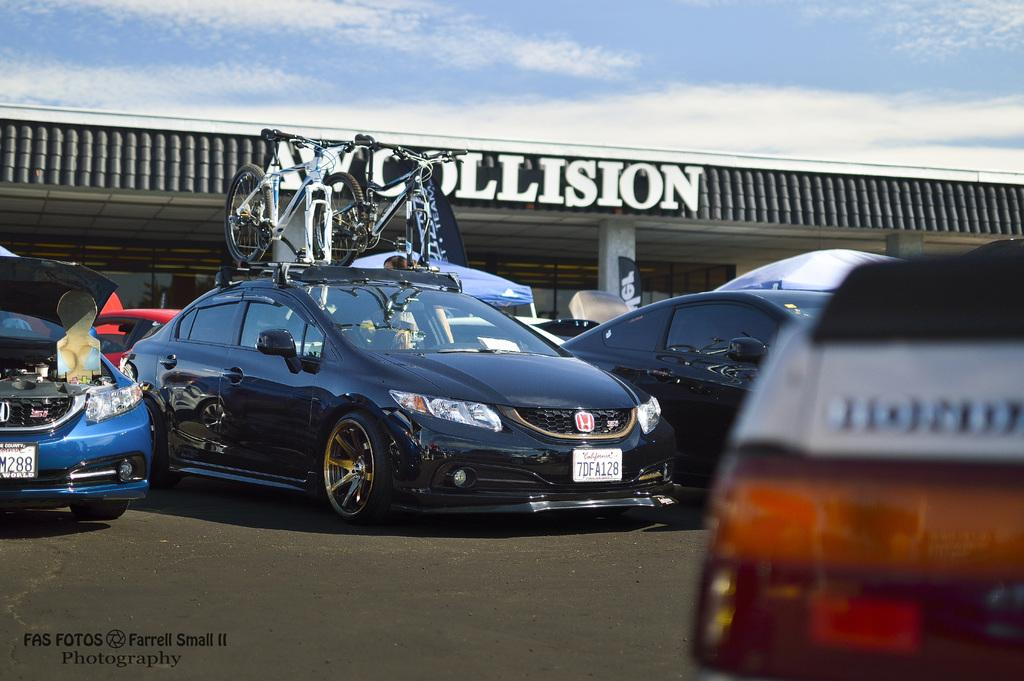<image>
Render a clear and concise summary of the photo. collision is written on the roof of a building 